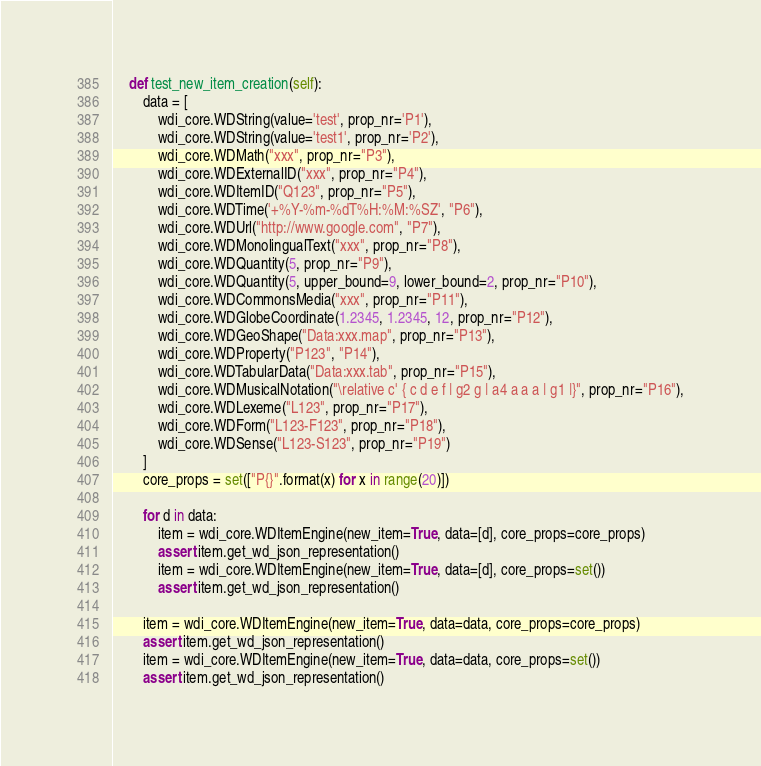<code> <loc_0><loc_0><loc_500><loc_500><_Python_>    def test_new_item_creation(self):
        data = [
            wdi_core.WDString(value='test', prop_nr='P1'),
            wdi_core.WDString(value='test1', prop_nr='P2'),
            wdi_core.WDMath("xxx", prop_nr="P3"),
            wdi_core.WDExternalID("xxx", prop_nr="P4"),
            wdi_core.WDItemID("Q123", prop_nr="P5"),
            wdi_core.WDTime('+%Y-%m-%dT%H:%M:%SZ', "P6"),
            wdi_core.WDUrl("http://www.google.com", "P7"),
            wdi_core.WDMonolingualText("xxx", prop_nr="P8"),
            wdi_core.WDQuantity(5, prop_nr="P9"),
            wdi_core.WDQuantity(5, upper_bound=9, lower_bound=2, prop_nr="P10"),
            wdi_core.WDCommonsMedia("xxx", prop_nr="P11"),
            wdi_core.WDGlobeCoordinate(1.2345, 1.2345, 12, prop_nr="P12"),
            wdi_core.WDGeoShape("Data:xxx.map", prop_nr="P13"),
            wdi_core.WDProperty("P123", "P14"),
            wdi_core.WDTabularData("Data:xxx.tab", prop_nr="P15"),
            wdi_core.WDMusicalNotation("\relative c' { c d e f | g2 g | a4 a a a | g1 |}", prop_nr="P16"),
            wdi_core.WDLexeme("L123", prop_nr="P17"),
            wdi_core.WDForm("L123-F123", prop_nr="P18"),
            wdi_core.WDSense("L123-S123", prop_nr="P19")
        ]
        core_props = set(["P{}".format(x) for x in range(20)])

        for d in data:
            item = wdi_core.WDItemEngine(new_item=True, data=[d], core_props=core_props)
            assert item.get_wd_json_representation()
            item = wdi_core.WDItemEngine(new_item=True, data=[d], core_props=set())
            assert item.get_wd_json_representation()

        item = wdi_core.WDItemEngine(new_item=True, data=data, core_props=core_props)
        assert item.get_wd_json_representation()
        item = wdi_core.WDItemEngine(new_item=True, data=data, core_props=set())
        assert item.get_wd_json_representation()
</code> 